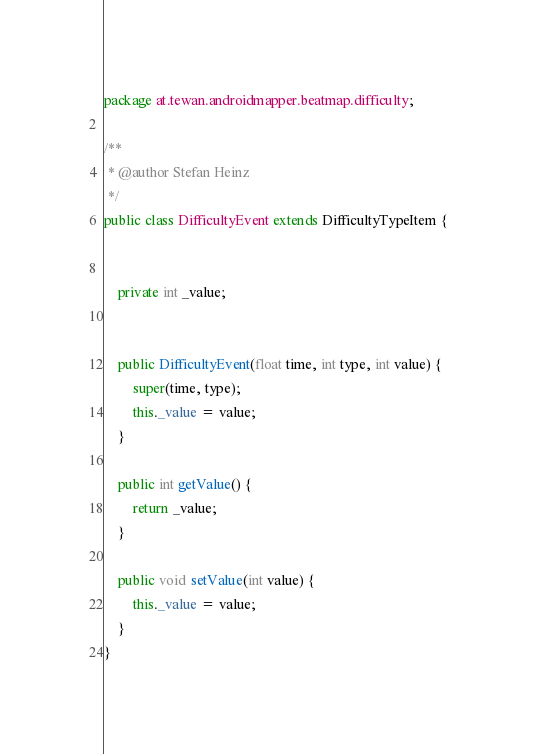<code> <loc_0><loc_0><loc_500><loc_500><_Java_>package at.tewan.androidmapper.beatmap.difficulty;

/**
 * @author Stefan Heinz
 */
public class DifficultyEvent extends DifficultyTypeItem {


    private int _value;


    public DifficultyEvent(float time, int type, int value) {
        super(time, type);
        this._value = value;
    }

    public int getValue() {
        return _value;
    }

    public void setValue(int value) {
        this._value = value;
    }
}
</code> 